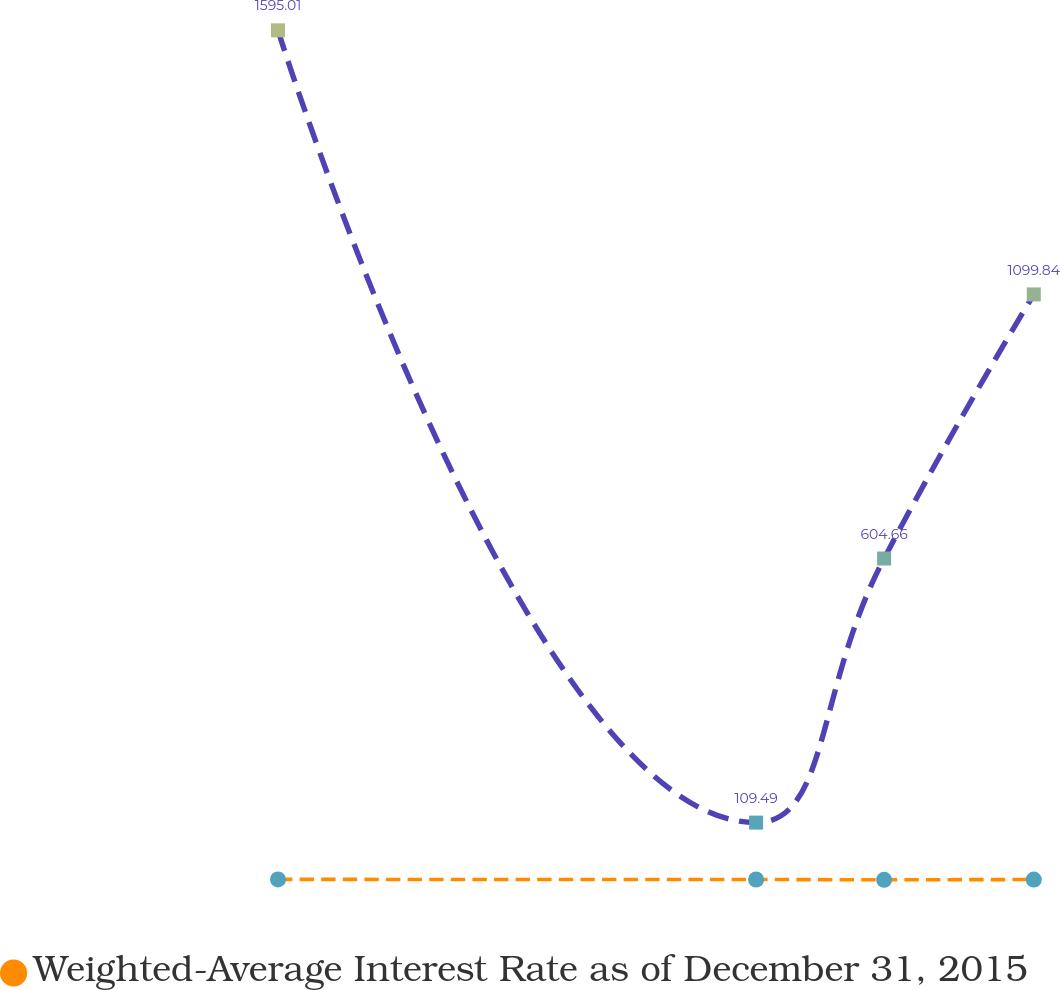<chart> <loc_0><loc_0><loc_500><loc_500><line_chart><ecel><fcel>Weighted-Average Interest Rate as of December 31, 2015<fcel>Unnamed: 2<nl><fcel>1836.96<fcel>2.98<fcel>1595.01<nl><fcel>2019.26<fcel>2.85<fcel>109.49<nl><fcel>2068.07<fcel>2.23<fcel>604.66<nl><fcel>2125.15<fcel>2.75<fcel>1099.84<nl><fcel>2325.03<fcel>3.27<fcel>5061.24<nl></chart> 